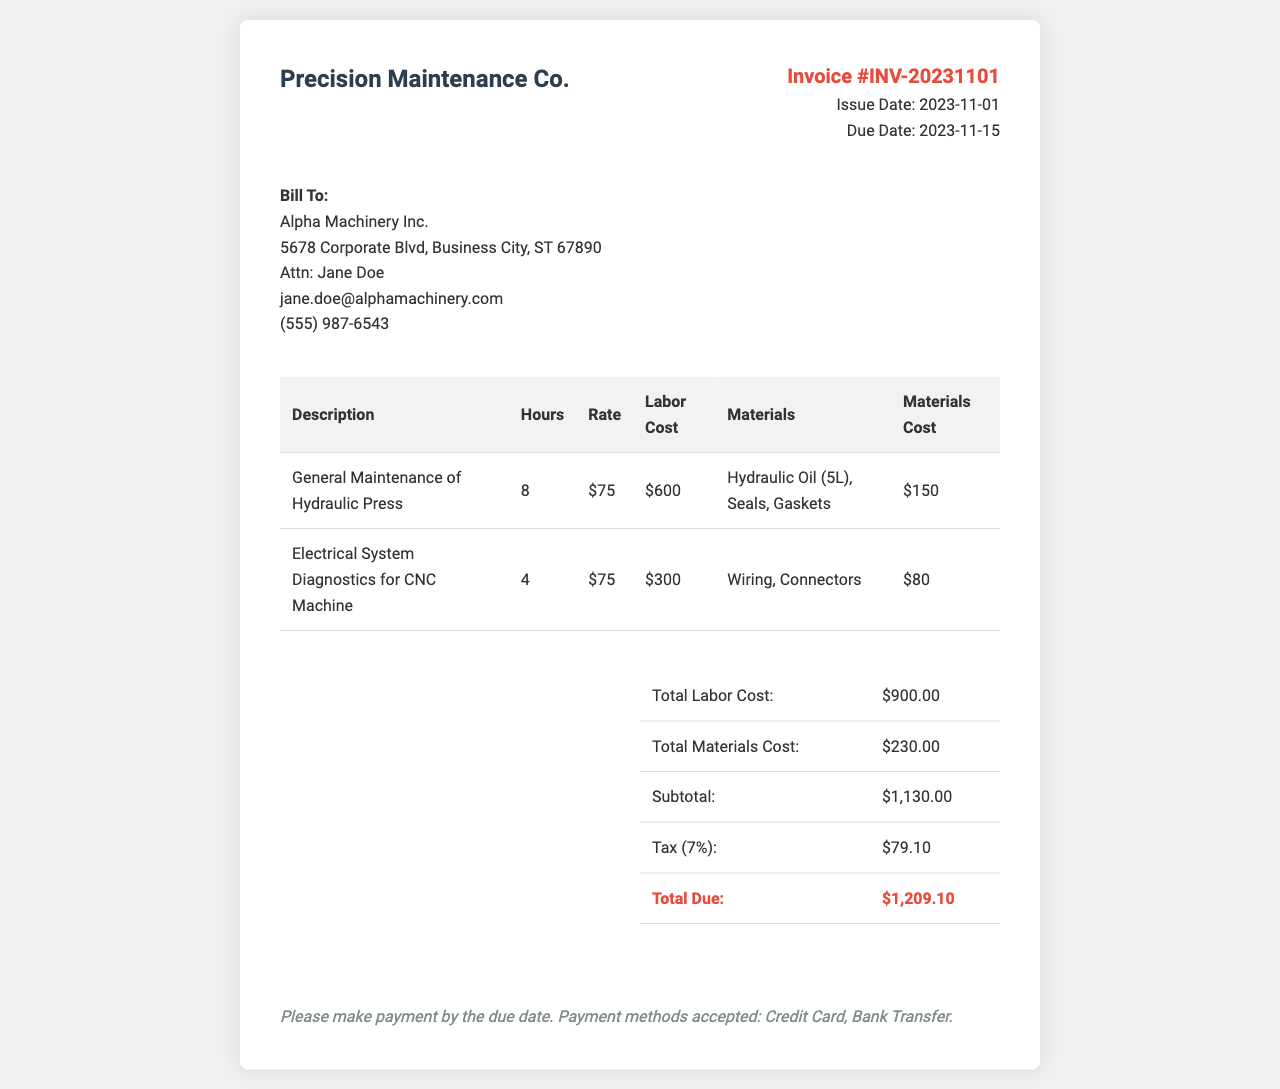what is the invoice number? The invoice number is listed clearly in the header section of the document.
Answer: INV-20231101 who is the client? The client's name and details are provided in the bill to section of the document.
Answer: Alpha Machinery Inc what is the issue date of the invoice? The issue date is specified in the header of the invoice document.
Answer: 2023-11-01 how much is the tax amount? The tax amount is calculated as 7% of the subtotal mentioned in the invoice.
Answer: $79.10 what is the total due amount? The total due is displayed in the summary section of the document after including all costs and tax.
Answer: $1,209.10 how many hours were spent on general maintenance of the hydraulic press? The hours for this task are shown in the corresponding row of the invoice table.
Answer: 8 what items were included as materials for the hydraulic press? The materials used for the hydraulic press maintenance are detailed in the materials column of the invoice.
Answer: Hydraulic Oil (5L), Seals, Gaskets what payment methods are accepted? The acceptable payment methods are stated in the payment terms at the bottom of the invoice.
Answer: Credit Card, Bank Transfer what is the subtotal amount before tax? The subtotal is calculated by adding total labor and materials costs shown in the summary table.
Answer: $1,130.00 